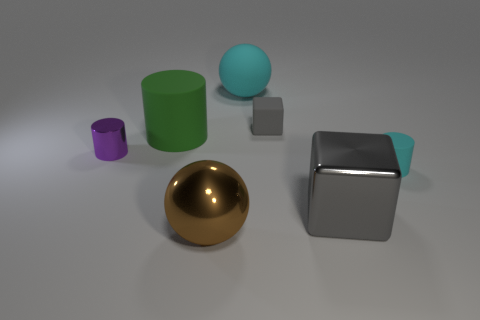Subtract all green cylinders. Subtract all yellow cubes. How many cylinders are left? 2 Add 2 tiny blue metallic things. How many objects exist? 9 Subtract all cylinders. How many objects are left? 4 Subtract 0 red blocks. How many objects are left? 7 Subtract all tiny purple rubber spheres. Subtract all metallic cylinders. How many objects are left? 6 Add 1 big spheres. How many big spheres are left? 3 Add 7 small metallic cylinders. How many small metallic cylinders exist? 8 